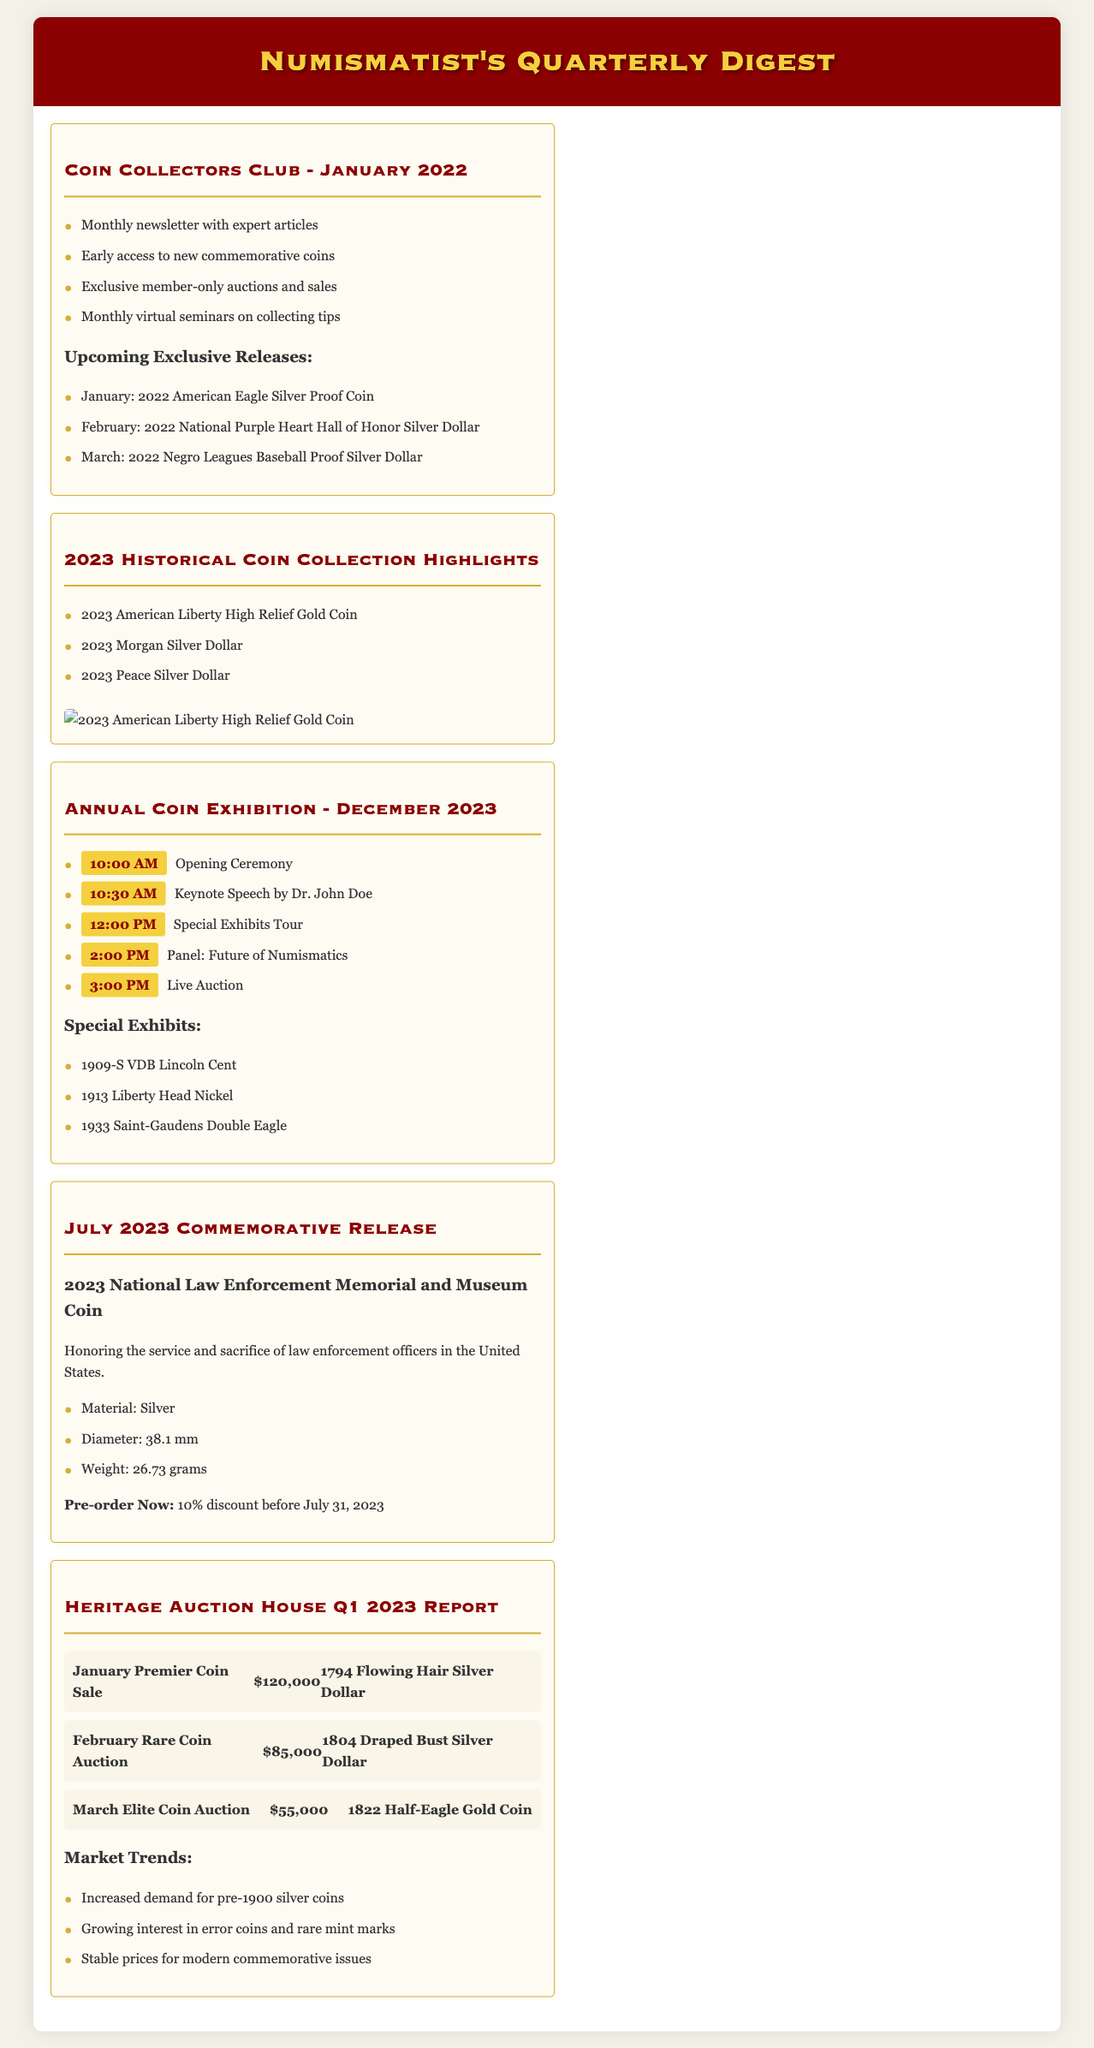What are the benefits of joining the Coin Collectors Club? The document lists benefits like a monthly newsletter, early access to coins, exclusive auctions, and monthly seminars.
Answer: Monthly newsletter with expert articles, early access to new commemorative coins, exclusive member-only auctions and sales, monthly virtual seminars on collecting tips What is the first exclusive release for January 2022? The document specifies the first exclusive release for January 2022 as the American Eagle Silver Proof Coin.
Answer: 2022 American Eagle Silver Proof Coin Which key speaker is scheduled for the Annual Coin Exhibition in December 2023? Dr. John Doe is mentioned as the keynote speaker for the event in the document.
Answer: Dr. John Doe What is the diameter of the July 2023 commemorative coin? The document provides the diameter of the coin as 38.1 mm.
Answer: 38.1 mm How much was the highest bid in the January Premier Coin Sale? The document notes that the highest bid in January was $120,000.
Answer: $120,000 What significant coin is included in the special exhibits of the Annual Coin Exhibition? The document lists the 1933 Saint-Gaudens Double Eagle as one of the significant coins in the special exhibits.
Answer: 1933 Saint-Gaudens Double Eagle How long is the pre-order discount valid for the July 2023 commemorative coin? The document states that the pre-order discount is valid until July 31, 2023.
Answer: Until July 31, 2023 What design elements are used in the product catalog for the historical coin collection? The document describes the design as using vintage parchment and gold-leaf accents.
Answer: Vintage parchment and gold-leaf accents 